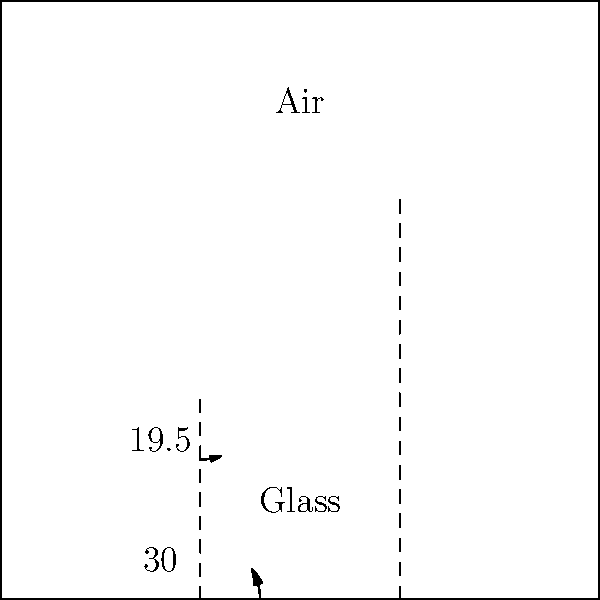A light ray enters a glass block from air at an angle of $30°$ to the normal. If the refractive index of glass is 1.5, what is the angle of refraction inside the glass? How might this concept be applied in natural language processing for document imaging and preservation? To solve this problem, we'll use Snell's Law and then relate it to document preservation:

1) Snell's Law states: $n_1 \sin(\theta_1) = n_2 \sin(\theta_2)$
   Where $n_1$ and $n_2$ are the refractive indices, and $\theta_1$ and $\theta_2$ are the angles of incidence and refraction.

2) We know:
   - $n_1 = 1$ (air)
   - $n_2 = 1.5$ (glass)
   - $\theta_1 = 30°$
   - We need to find $\theta_2$

3) Substituting into Snell's Law:
   $1 \sin(30°) = 1.5 \sin(\theta_2)$

4) Solving for $\theta_2$:
   $\sin(\theta_2) = \frac{1 \sin(30°)}{1.5} = \frac{\sin(30°)}{1.5}$
   $\theta_2 = \arcsin(\frac{\sin(30°)}{1.5}) \approx 19.5°$

5) Application to NLP and document preservation:
   Understanding light refraction is crucial in document imaging. When digitizing old documents, the angle and intensity of light can affect image quality. By applying principles of optics, we can:
   - Optimize camera angles to reduce glare
   - Adjust lighting to enhance contrast and readability
   - Develop algorithms to correct for distortions caused by document curvature
   - Improve OCR (Optical Character Recognition) accuracy by accounting for light interactions with different document materials

   These improvements in imaging can lead to better input for NLP tasks, enhancing text extraction, analysis, and preservation of historical documents.
Answer: $19.5°$ 